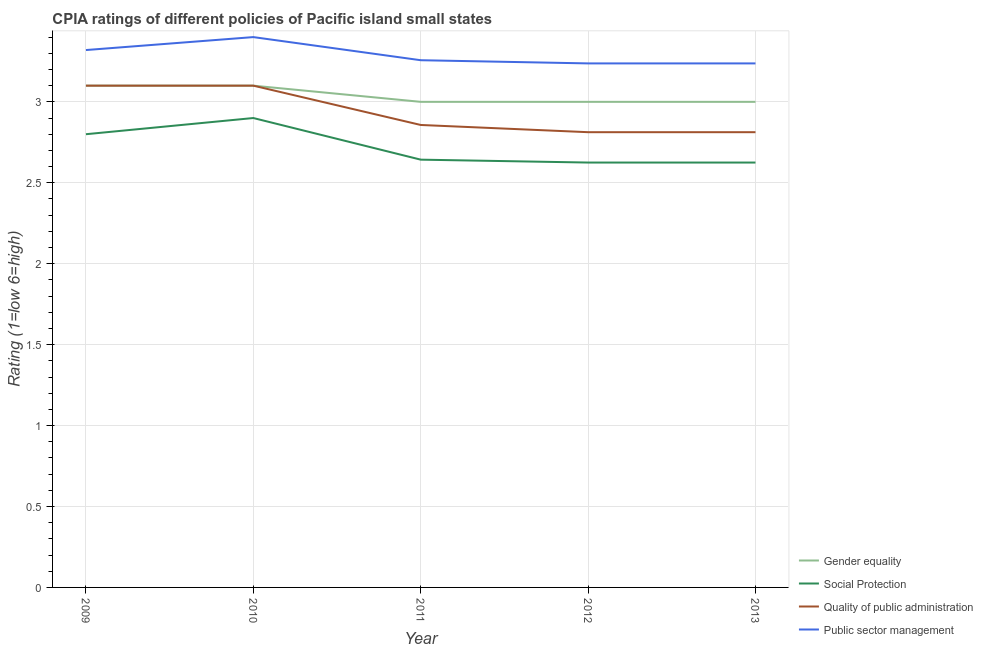How many different coloured lines are there?
Keep it short and to the point. 4. Does the line corresponding to cpia rating of public sector management intersect with the line corresponding to cpia rating of gender equality?
Your answer should be compact. No. Is the number of lines equal to the number of legend labels?
Ensure brevity in your answer.  Yes. Across all years, what is the minimum cpia rating of quality of public administration?
Offer a terse response. 2.81. What is the total cpia rating of public sector management in the graph?
Provide a short and direct response. 16.45. What is the difference between the cpia rating of gender equality in 2009 and that in 2010?
Your answer should be compact. 0. What is the difference between the cpia rating of gender equality in 2011 and the cpia rating of public sector management in 2013?
Your response must be concise. -0.24. What is the average cpia rating of gender equality per year?
Provide a short and direct response. 3.04. In the year 2011, what is the difference between the cpia rating of social protection and cpia rating of public sector management?
Offer a terse response. -0.61. In how many years, is the cpia rating of quality of public administration greater than 1.7?
Offer a very short reply. 5. What is the ratio of the cpia rating of quality of public administration in 2012 to that in 2013?
Give a very brief answer. 1. Is the difference between the cpia rating of gender equality in 2009 and 2010 greater than the difference between the cpia rating of public sector management in 2009 and 2010?
Your response must be concise. Yes. What is the difference between the highest and the lowest cpia rating of public sector management?
Give a very brief answer. 0.16. Is the sum of the cpia rating of public sector management in 2009 and 2010 greater than the maximum cpia rating of quality of public administration across all years?
Offer a very short reply. Yes. Is it the case that in every year, the sum of the cpia rating of quality of public administration and cpia rating of public sector management is greater than the sum of cpia rating of gender equality and cpia rating of social protection?
Offer a terse response. No. Does the cpia rating of social protection monotonically increase over the years?
Ensure brevity in your answer.  No. Is the cpia rating of social protection strictly greater than the cpia rating of gender equality over the years?
Give a very brief answer. No. Is the cpia rating of public sector management strictly less than the cpia rating of quality of public administration over the years?
Make the answer very short. No. How many lines are there?
Your answer should be compact. 4. Does the graph contain grids?
Your answer should be compact. Yes. Where does the legend appear in the graph?
Offer a very short reply. Bottom right. What is the title of the graph?
Provide a short and direct response. CPIA ratings of different policies of Pacific island small states. What is the label or title of the Y-axis?
Your answer should be very brief. Rating (1=low 6=high). What is the Rating (1=low 6=high) of Gender equality in 2009?
Keep it short and to the point. 3.1. What is the Rating (1=low 6=high) in Social Protection in 2009?
Provide a short and direct response. 2.8. What is the Rating (1=low 6=high) of Quality of public administration in 2009?
Make the answer very short. 3.1. What is the Rating (1=low 6=high) in Public sector management in 2009?
Provide a short and direct response. 3.32. What is the Rating (1=low 6=high) in Gender equality in 2010?
Offer a terse response. 3.1. What is the Rating (1=low 6=high) of Quality of public administration in 2010?
Make the answer very short. 3.1. What is the Rating (1=low 6=high) of Public sector management in 2010?
Provide a short and direct response. 3.4. What is the Rating (1=low 6=high) of Gender equality in 2011?
Your response must be concise. 3. What is the Rating (1=low 6=high) in Social Protection in 2011?
Your response must be concise. 2.64. What is the Rating (1=low 6=high) in Quality of public administration in 2011?
Your answer should be compact. 2.86. What is the Rating (1=low 6=high) in Public sector management in 2011?
Your answer should be very brief. 3.26. What is the Rating (1=low 6=high) in Gender equality in 2012?
Offer a very short reply. 3. What is the Rating (1=low 6=high) in Social Protection in 2012?
Provide a short and direct response. 2.62. What is the Rating (1=low 6=high) in Quality of public administration in 2012?
Your response must be concise. 2.81. What is the Rating (1=low 6=high) in Public sector management in 2012?
Your response must be concise. 3.24. What is the Rating (1=low 6=high) in Gender equality in 2013?
Keep it short and to the point. 3. What is the Rating (1=low 6=high) of Social Protection in 2013?
Make the answer very short. 2.62. What is the Rating (1=low 6=high) in Quality of public administration in 2013?
Your answer should be compact. 2.81. What is the Rating (1=low 6=high) of Public sector management in 2013?
Give a very brief answer. 3.24. Across all years, what is the maximum Rating (1=low 6=high) of Social Protection?
Provide a short and direct response. 2.9. Across all years, what is the maximum Rating (1=low 6=high) in Public sector management?
Give a very brief answer. 3.4. Across all years, what is the minimum Rating (1=low 6=high) in Gender equality?
Your response must be concise. 3. Across all years, what is the minimum Rating (1=low 6=high) in Social Protection?
Offer a terse response. 2.62. Across all years, what is the minimum Rating (1=low 6=high) of Quality of public administration?
Your response must be concise. 2.81. Across all years, what is the minimum Rating (1=low 6=high) in Public sector management?
Your answer should be compact. 3.24. What is the total Rating (1=low 6=high) in Social Protection in the graph?
Make the answer very short. 13.59. What is the total Rating (1=low 6=high) of Quality of public administration in the graph?
Provide a short and direct response. 14.68. What is the total Rating (1=low 6=high) of Public sector management in the graph?
Keep it short and to the point. 16.45. What is the difference between the Rating (1=low 6=high) of Quality of public administration in 2009 and that in 2010?
Provide a succinct answer. 0. What is the difference between the Rating (1=low 6=high) of Public sector management in 2009 and that in 2010?
Keep it short and to the point. -0.08. What is the difference between the Rating (1=low 6=high) of Gender equality in 2009 and that in 2011?
Your response must be concise. 0.1. What is the difference between the Rating (1=low 6=high) of Social Protection in 2009 and that in 2011?
Offer a very short reply. 0.16. What is the difference between the Rating (1=low 6=high) of Quality of public administration in 2009 and that in 2011?
Ensure brevity in your answer.  0.24. What is the difference between the Rating (1=low 6=high) in Public sector management in 2009 and that in 2011?
Provide a short and direct response. 0.06. What is the difference between the Rating (1=low 6=high) in Social Protection in 2009 and that in 2012?
Make the answer very short. 0.17. What is the difference between the Rating (1=low 6=high) of Quality of public administration in 2009 and that in 2012?
Provide a succinct answer. 0.29. What is the difference between the Rating (1=low 6=high) in Public sector management in 2009 and that in 2012?
Keep it short and to the point. 0.08. What is the difference between the Rating (1=low 6=high) in Social Protection in 2009 and that in 2013?
Ensure brevity in your answer.  0.17. What is the difference between the Rating (1=low 6=high) in Quality of public administration in 2009 and that in 2013?
Offer a terse response. 0.29. What is the difference between the Rating (1=low 6=high) in Public sector management in 2009 and that in 2013?
Give a very brief answer. 0.08. What is the difference between the Rating (1=low 6=high) in Gender equality in 2010 and that in 2011?
Give a very brief answer. 0.1. What is the difference between the Rating (1=low 6=high) in Social Protection in 2010 and that in 2011?
Provide a succinct answer. 0.26. What is the difference between the Rating (1=low 6=high) in Quality of public administration in 2010 and that in 2011?
Make the answer very short. 0.24. What is the difference between the Rating (1=low 6=high) in Public sector management in 2010 and that in 2011?
Provide a succinct answer. 0.14. What is the difference between the Rating (1=low 6=high) of Social Protection in 2010 and that in 2012?
Your response must be concise. 0.28. What is the difference between the Rating (1=low 6=high) in Quality of public administration in 2010 and that in 2012?
Offer a very short reply. 0.29. What is the difference between the Rating (1=low 6=high) of Public sector management in 2010 and that in 2012?
Ensure brevity in your answer.  0.16. What is the difference between the Rating (1=low 6=high) of Social Protection in 2010 and that in 2013?
Give a very brief answer. 0.28. What is the difference between the Rating (1=low 6=high) in Quality of public administration in 2010 and that in 2013?
Your answer should be very brief. 0.29. What is the difference between the Rating (1=low 6=high) of Public sector management in 2010 and that in 2013?
Offer a very short reply. 0.16. What is the difference between the Rating (1=low 6=high) in Gender equality in 2011 and that in 2012?
Your answer should be compact. 0. What is the difference between the Rating (1=low 6=high) in Social Protection in 2011 and that in 2012?
Offer a very short reply. 0.02. What is the difference between the Rating (1=low 6=high) in Quality of public administration in 2011 and that in 2012?
Give a very brief answer. 0.04. What is the difference between the Rating (1=low 6=high) in Public sector management in 2011 and that in 2012?
Provide a short and direct response. 0.02. What is the difference between the Rating (1=low 6=high) in Social Protection in 2011 and that in 2013?
Keep it short and to the point. 0.02. What is the difference between the Rating (1=low 6=high) in Quality of public administration in 2011 and that in 2013?
Provide a succinct answer. 0.04. What is the difference between the Rating (1=low 6=high) in Public sector management in 2011 and that in 2013?
Ensure brevity in your answer.  0.02. What is the difference between the Rating (1=low 6=high) in Gender equality in 2012 and that in 2013?
Your answer should be very brief. 0. What is the difference between the Rating (1=low 6=high) of Gender equality in 2009 and the Rating (1=low 6=high) of Social Protection in 2010?
Offer a terse response. 0.2. What is the difference between the Rating (1=low 6=high) of Gender equality in 2009 and the Rating (1=low 6=high) of Public sector management in 2010?
Your answer should be compact. -0.3. What is the difference between the Rating (1=low 6=high) of Quality of public administration in 2009 and the Rating (1=low 6=high) of Public sector management in 2010?
Offer a very short reply. -0.3. What is the difference between the Rating (1=low 6=high) in Gender equality in 2009 and the Rating (1=low 6=high) in Social Protection in 2011?
Provide a short and direct response. 0.46. What is the difference between the Rating (1=low 6=high) of Gender equality in 2009 and the Rating (1=low 6=high) of Quality of public administration in 2011?
Your answer should be very brief. 0.24. What is the difference between the Rating (1=low 6=high) in Gender equality in 2009 and the Rating (1=low 6=high) in Public sector management in 2011?
Your answer should be very brief. -0.16. What is the difference between the Rating (1=low 6=high) in Social Protection in 2009 and the Rating (1=low 6=high) in Quality of public administration in 2011?
Provide a succinct answer. -0.06. What is the difference between the Rating (1=low 6=high) of Social Protection in 2009 and the Rating (1=low 6=high) of Public sector management in 2011?
Provide a succinct answer. -0.46. What is the difference between the Rating (1=low 6=high) in Quality of public administration in 2009 and the Rating (1=low 6=high) in Public sector management in 2011?
Provide a short and direct response. -0.16. What is the difference between the Rating (1=low 6=high) in Gender equality in 2009 and the Rating (1=low 6=high) in Social Protection in 2012?
Keep it short and to the point. 0.47. What is the difference between the Rating (1=low 6=high) of Gender equality in 2009 and the Rating (1=low 6=high) of Quality of public administration in 2012?
Offer a terse response. 0.29. What is the difference between the Rating (1=low 6=high) in Gender equality in 2009 and the Rating (1=low 6=high) in Public sector management in 2012?
Your response must be concise. -0.14. What is the difference between the Rating (1=low 6=high) in Social Protection in 2009 and the Rating (1=low 6=high) in Quality of public administration in 2012?
Provide a short and direct response. -0.01. What is the difference between the Rating (1=low 6=high) of Social Protection in 2009 and the Rating (1=low 6=high) of Public sector management in 2012?
Ensure brevity in your answer.  -0.44. What is the difference between the Rating (1=low 6=high) in Quality of public administration in 2009 and the Rating (1=low 6=high) in Public sector management in 2012?
Ensure brevity in your answer.  -0.14. What is the difference between the Rating (1=low 6=high) of Gender equality in 2009 and the Rating (1=low 6=high) of Social Protection in 2013?
Make the answer very short. 0.47. What is the difference between the Rating (1=low 6=high) in Gender equality in 2009 and the Rating (1=low 6=high) in Quality of public administration in 2013?
Provide a short and direct response. 0.29. What is the difference between the Rating (1=low 6=high) in Gender equality in 2009 and the Rating (1=low 6=high) in Public sector management in 2013?
Provide a short and direct response. -0.14. What is the difference between the Rating (1=low 6=high) in Social Protection in 2009 and the Rating (1=low 6=high) in Quality of public administration in 2013?
Make the answer very short. -0.01. What is the difference between the Rating (1=low 6=high) in Social Protection in 2009 and the Rating (1=low 6=high) in Public sector management in 2013?
Offer a terse response. -0.44. What is the difference between the Rating (1=low 6=high) in Quality of public administration in 2009 and the Rating (1=low 6=high) in Public sector management in 2013?
Your answer should be compact. -0.14. What is the difference between the Rating (1=low 6=high) in Gender equality in 2010 and the Rating (1=low 6=high) in Social Protection in 2011?
Provide a succinct answer. 0.46. What is the difference between the Rating (1=low 6=high) in Gender equality in 2010 and the Rating (1=low 6=high) in Quality of public administration in 2011?
Make the answer very short. 0.24. What is the difference between the Rating (1=low 6=high) of Gender equality in 2010 and the Rating (1=low 6=high) of Public sector management in 2011?
Your answer should be very brief. -0.16. What is the difference between the Rating (1=low 6=high) of Social Protection in 2010 and the Rating (1=low 6=high) of Quality of public administration in 2011?
Your response must be concise. 0.04. What is the difference between the Rating (1=low 6=high) of Social Protection in 2010 and the Rating (1=low 6=high) of Public sector management in 2011?
Your response must be concise. -0.36. What is the difference between the Rating (1=low 6=high) of Quality of public administration in 2010 and the Rating (1=low 6=high) of Public sector management in 2011?
Your response must be concise. -0.16. What is the difference between the Rating (1=low 6=high) in Gender equality in 2010 and the Rating (1=low 6=high) in Social Protection in 2012?
Make the answer very short. 0.47. What is the difference between the Rating (1=low 6=high) of Gender equality in 2010 and the Rating (1=low 6=high) of Quality of public administration in 2012?
Ensure brevity in your answer.  0.29. What is the difference between the Rating (1=low 6=high) in Gender equality in 2010 and the Rating (1=low 6=high) in Public sector management in 2012?
Your answer should be very brief. -0.14. What is the difference between the Rating (1=low 6=high) of Social Protection in 2010 and the Rating (1=low 6=high) of Quality of public administration in 2012?
Your answer should be compact. 0.09. What is the difference between the Rating (1=low 6=high) of Social Protection in 2010 and the Rating (1=low 6=high) of Public sector management in 2012?
Offer a very short reply. -0.34. What is the difference between the Rating (1=low 6=high) in Quality of public administration in 2010 and the Rating (1=low 6=high) in Public sector management in 2012?
Provide a succinct answer. -0.14. What is the difference between the Rating (1=low 6=high) of Gender equality in 2010 and the Rating (1=low 6=high) of Social Protection in 2013?
Your answer should be very brief. 0.47. What is the difference between the Rating (1=low 6=high) in Gender equality in 2010 and the Rating (1=low 6=high) in Quality of public administration in 2013?
Ensure brevity in your answer.  0.29. What is the difference between the Rating (1=low 6=high) of Gender equality in 2010 and the Rating (1=low 6=high) of Public sector management in 2013?
Make the answer very short. -0.14. What is the difference between the Rating (1=low 6=high) in Social Protection in 2010 and the Rating (1=low 6=high) in Quality of public administration in 2013?
Your answer should be compact. 0.09. What is the difference between the Rating (1=low 6=high) in Social Protection in 2010 and the Rating (1=low 6=high) in Public sector management in 2013?
Your response must be concise. -0.34. What is the difference between the Rating (1=low 6=high) of Quality of public administration in 2010 and the Rating (1=low 6=high) of Public sector management in 2013?
Provide a succinct answer. -0.14. What is the difference between the Rating (1=low 6=high) in Gender equality in 2011 and the Rating (1=low 6=high) in Quality of public administration in 2012?
Make the answer very short. 0.19. What is the difference between the Rating (1=low 6=high) in Gender equality in 2011 and the Rating (1=low 6=high) in Public sector management in 2012?
Ensure brevity in your answer.  -0.24. What is the difference between the Rating (1=low 6=high) of Social Protection in 2011 and the Rating (1=low 6=high) of Quality of public administration in 2012?
Provide a succinct answer. -0.17. What is the difference between the Rating (1=low 6=high) of Social Protection in 2011 and the Rating (1=low 6=high) of Public sector management in 2012?
Give a very brief answer. -0.59. What is the difference between the Rating (1=low 6=high) in Quality of public administration in 2011 and the Rating (1=low 6=high) in Public sector management in 2012?
Provide a short and direct response. -0.38. What is the difference between the Rating (1=low 6=high) of Gender equality in 2011 and the Rating (1=low 6=high) of Social Protection in 2013?
Make the answer very short. 0.38. What is the difference between the Rating (1=low 6=high) of Gender equality in 2011 and the Rating (1=low 6=high) of Quality of public administration in 2013?
Offer a terse response. 0.19. What is the difference between the Rating (1=low 6=high) of Gender equality in 2011 and the Rating (1=low 6=high) of Public sector management in 2013?
Your answer should be very brief. -0.24. What is the difference between the Rating (1=low 6=high) of Social Protection in 2011 and the Rating (1=low 6=high) of Quality of public administration in 2013?
Make the answer very short. -0.17. What is the difference between the Rating (1=low 6=high) of Social Protection in 2011 and the Rating (1=low 6=high) of Public sector management in 2013?
Provide a succinct answer. -0.59. What is the difference between the Rating (1=low 6=high) in Quality of public administration in 2011 and the Rating (1=low 6=high) in Public sector management in 2013?
Give a very brief answer. -0.38. What is the difference between the Rating (1=low 6=high) of Gender equality in 2012 and the Rating (1=low 6=high) of Social Protection in 2013?
Provide a succinct answer. 0.38. What is the difference between the Rating (1=low 6=high) in Gender equality in 2012 and the Rating (1=low 6=high) in Quality of public administration in 2013?
Your answer should be very brief. 0.19. What is the difference between the Rating (1=low 6=high) in Gender equality in 2012 and the Rating (1=low 6=high) in Public sector management in 2013?
Your answer should be compact. -0.24. What is the difference between the Rating (1=low 6=high) of Social Protection in 2012 and the Rating (1=low 6=high) of Quality of public administration in 2013?
Offer a very short reply. -0.19. What is the difference between the Rating (1=low 6=high) in Social Protection in 2012 and the Rating (1=low 6=high) in Public sector management in 2013?
Your answer should be very brief. -0.61. What is the difference between the Rating (1=low 6=high) in Quality of public administration in 2012 and the Rating (1=low 6=high) in Public sector management in 2013?
Provide a short and direct response. -0.42. What is the average Rating (1=low 6=high) in Gender equality per year?
Keep it short and to the point. 3.04. What is the average Rating (1=low 6=high) of Social Protection per year?
Keep it short and to the point. 2.72. What is the average Rating (1=low 6=high) of Quality of public administration per year?
Make the answer very short. 2.94. What is the average Rating (1=low 6=high) of Public sector management per year?
Keep it short and to the point. 3.29. In the year 2009, what is the difference between the Rating (1=low 6=high) of Gender equality and Rating (1=low 6=high) of Quality of public administration?
Your answer should be very brief. 0. In the year 2009, what is the difference between the Rating (1=low 6=high) of Gender equality and Rating (1=low 6=high) of Public sector management?
Make the answer very short. -0.22. In the year 2009, what is the difference between the Rating (1=low 6=high) of Social Protection and Rating (1=low 6=high) of Public sector management?
Make the answer very short. -0.52. In the year 2009, what is the difference between the Rating (1=low 6=high) of Quality of public administration and Rating (1=low 6=high) of Public sector management?
Offer a very short reply. -0.22. In the year 2010, what is the difference between the Rating (1=low 6=high) of Gender equality and Rating (1=low 6=high) of Quality of public administration?
Give a very brief answer. 0. In the year 2010, what is the difference between the Rating (1=low 6=high) in Social Protection and Rating (1=low 6=high) in Quality of public administration?
Provide a short and direct response. -0.2. In the year 2011, what is the difference between the Rating (1=low 6=high) of Gender equality and Rating (1=low 6=high) of Social Protection?
Offer a very short reply. 0.36. In the year 2011, what is the difference between the Rating (1=low 6=high) of Gender equality and Rating (1=low 6=high) of Quality of public administration?
Ensure brevity in your answer.  0.14. In the year 2011, what is the difference between the Rating (1=low 6=high) in Gender equality and Rating (1=low 6=high) in Public sector management?
Provide a short and direct response. -0.26. In the year 2011, what is the difference between the Rating (1=low 6=high) of Social Protection and Rating (1=low 6=high) of Quality of public administration?
Provide a succinct answer. -0.21. In the year 2011, what is the difference between the Rating (1=low 6=high) of Social Protection and Rating (1=low 6=high) of Public sector management?
Your answer should be compact. -0.61. In the year 2011, what is the difference between the Rating (1=low 6=high) of Quality of public administration and Rating (1=low 6=high) of Public sector management?
Your response must be concise. -0.4. In the year 2012, what is the difference between the Rating (1=low 6=high) in Gender equality and Rating (1=low 6=high) in Quality of public administration?
Ensure brevity in your answer.  0.19. In the year 2012, what is the difference between the Rating (1=low 6=high) of Gender equality and Rating (1=low 6=high) of Public sector management?
Offer a very short reply. -0.24. In the year 2012, what is the difference between the Rating (1=low 6=high) of Social Protection and Rating (1=low 6=high) of Quality of public administration?
Keep it short and to the point. -0.19. In the year 2012, what is the difference between the Rating (1=low 6=high) in Social Protection and Rating (1=low 6=high) in Public sector management?
Keep it short and to the point. -0.61. In the year 2012, what is the difference between the Rating (1=low 6=high) of Quality of public administration and Rating (1=low 6=high) of Public sector management?
Provide a short and direct response. -0.42. In the year 2013, what is the difference between the Rating (1=low 6=high) in Gender equality and Rating (1=low 6=high) in Social Protection?
Offer a terse response. 0.38. In the year 2013, what is the difference between the Rating (1=low 6=high) of Gender equality and Rating (1=low 6=high) of Quality of public administration?
Keep it short and to the point. 0.19. In the year 2013, what is the difference between the Rating (1=low 6=high) of Gender equality and Rating (1=low 6=high) of Public sector management?
Make the answer very short. -0.24. In the year 2013, what is the difference between the Rating (1=low 6=high) of Social Protection and Rating (1=low 6=high) of Quality of public administration?
Provide a short and direct response. -0.19. In the year 2013, what is the difference between the Rating (1=low 6=high) of Social Protection and Rating (1=low 6=high) of Public sector management?
Provide a short and direct response. -0.61. In the year 2013, what is the difference between the Rating (1=low 6=high) of Quality of public administration and Rating (1=low 6=high) of Public sector management?
Your answer should be very brief. -0.42. What is the ratio of the Rating (1=low 6=high) in Social Protection in 2009 to that in 2010?
Offer a very short reply. 0.97. What is the ratio of the Rating (1=low 6=high) of Quality of public administration in 2009 to that in 2010?
Your answer should be compact. 1. What is the ratio of the Rating (1=low 6=high) in Public sector management in 2009 to that in 2010?
Your answer should be very brief. 0.98. What is the ratio of the Rating (1=low 6=high) in Social Protection in 2009 to that in 2011?
Make the answer very short. 1.06. What is the ratio of the Rating (1=low 6=high) of Quality of public administration in 2009 to that in 2011?
Provide a short and direct response. 1.08. What is the ratio of the Rating (1=low 6=high) of Public sector management in 2009 to that in 2011?
Give a very brief answer. 1.02. What is the ratio of the Rating (1=low 6=high) of Gender equality in 2009 to that in 2012?
Your response must be concise. 1.03. What is the ratio of the Rating (1=low 6=high) in Social Protection in 2009 to that in 2012?
Your response must be concise. 1.07. What is the ratio of the Rating (1=low 6=high) of Quality of public administration in 2009 to that in 2012?
Offer a very short reply. 1.1. What is the ratio of the Rating (1=low 6=high) of Public sector management in 2009 to that in 2012?
Your answer should be compact. 1.03. What is the ratio of the Rating (1=low 6=high) of Social Protection in 2009 to that in 2013?
Offer a terse response. 1.07. What is the ratio of the Rating (1=low 6=high) of Quality of public administration in 2009 to that in 2013?
Make the answer very short. 1.1. What is the ratio of the Rating (1=low 6=high) of Public sector management in 2009 to that in 2013?
Your response must be concise. 1.03. What is the ratio of the Rating (1=low 6=high) of Gender equality in 2010 to that in 2011?
Give a very brief answer. 1.03. What is the ratio of the Rating (1=low 6=high) of Social Protection in 2010 to that in 2011?
Provide a short and direct response. 1.1. What is the ratio of the Rating (1=low 6=high) in Quality of public administration in 2010 to that in 2011?
Offer a terse response. 1.08. What is the ratio of the Rating (1=low 6=high) of Public sector management in 2010 to that in 2011?
Offer a terse response. 1.04. What is the ratio of the Rating (1=low 6=high) in Social Protection in 2010 to that in 2012?
Keep it short and to the point. 1.1. What is the ratio of the Rating (1=low 6=high) in Quality of public administration in 2010 to that in 2012?
Make the answer very short. 1.1. What is the ratio of the Rating (1=low 6=high) of Public sector management in 2010 to that in 2012?
Give a very brief answer. 1.05. What is the ratio of the Rating (1=low 6=high) of Gender equality in 2010 to that in 2013?
Keep it short and to the point. 1.03. What is the ratio of the Rating (1=low 6=high) of Social Protection in 2010 to that in 2013?
Offer a terse response. 1.1. What is the ratio of the Rating (1=low 6=high) of Quality of public administration in 2010 to that in 2013?
Keep it short and to the point. 1.1. What is the ratio of the Rating (1=low 6=high) in Public sector management in 2010 to that in 2013?
Give a very brief answer. 1.05. What is the ratio of the Rating (1=low 6=high) in Gender equality in 2011 to that in 2012?
Offer a terse response. 1. What is the ratio of the Rating (1=low 6=high) of Social Protection in 2011 to that in 2012?
Your answer should be very brief. 1.01. What is the ratio of the Rating (1=low 6=high) in Quality of public administration in 2011 to that in 2012?
Provide a short and direct response. 1.02. What is the ratio of the Rating (1=low 6=high) of Social Protection in 2011 to that in 2013?
Offer a terse response. 1.01. What is the ratio of the Rating (1=low 6=high) in Quality of public administration in 2011 to that in 2013?
Ensure brevity in your answer.  1.02. What is the ratio of the Rating (1=low 6=high) in Public sector management in 2011 to that in 2013?
Provide a short and direct response. 1.01. What is the ratio of the Rating (1=low 6=high) in Social Protection in 2012 to that in 2013?
Your answer should be very brief. 1. What is the ratio of the Rating (1=low 6=high) in Quality of public administration in 2012 to that in 2013?
Provide a short and direct response. 1. What is the ratio of the Rating (1=low 6=high) in Public sector management in 2012 to that in 2013?
Keep it short and to the point. 1. What is the difference between the highest and the second highest Rating (1=low 6=high) in Quality of public administration?
Your response must be concise. 0. What is the difference between the highest and the second highest Rating (1=low 6=high) of Public sector management?
Offer a very short reply. 0.08. What is the difference between the highest and the lowest Rating (1=low 6=high) of Gender equality?
Provide a succinct answer. 0.1. What is the difference between the highest and the lowest Rating (1=low 6=high) of Social Protection?
Your answer should be compact. 0.28. What is the difference between the highest and the lowest Rating (1=low 6=high) in Quality of public administration?
Give a very brief answer. 0.29. What is the difference between the highest and the lowest Rating (1=low 6=high) of Public sector management?
Your answer should be very brief. 0.16. 